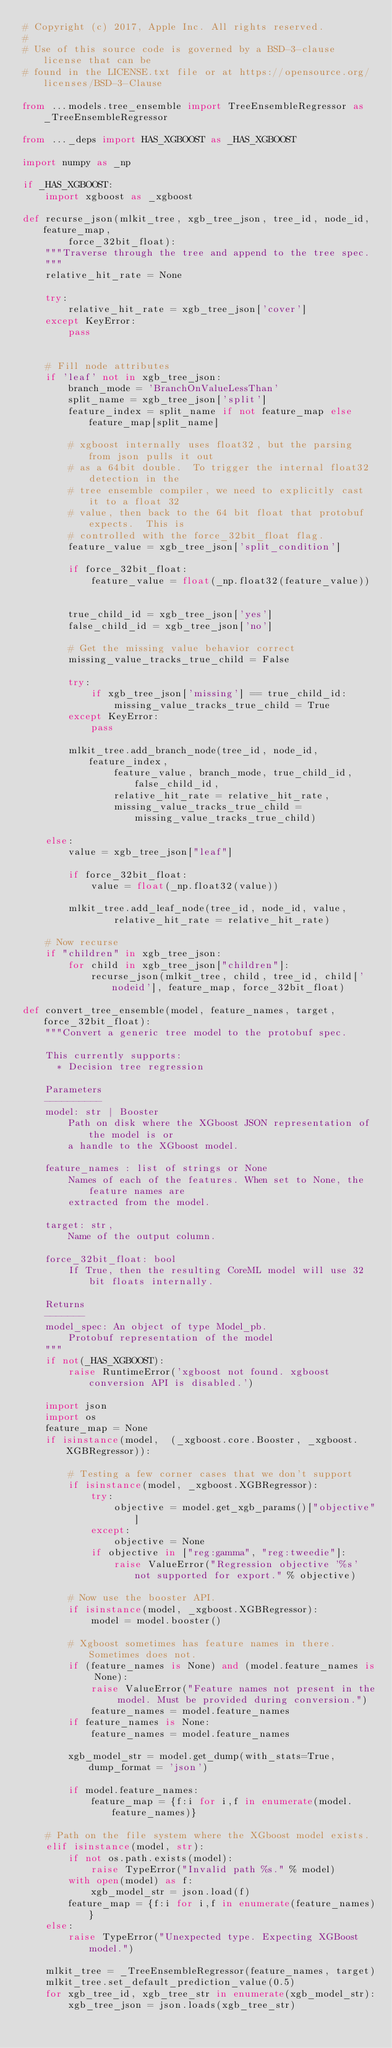<code> <loc_0><loc_0><loc_500><loc_500><_Python_># Copyright (c) 2017, Apple Inc. All rights reserved.
#
# Use of this source code is governed by a BSD-3-clause license that can be
# found in the LICENSE.txt file or at https://opensource.org/licenses/BSD-3-Clause

from ...models.tree_ensemble import TreeEnsembleRegressor as _TreeEnsembleRegressor

from ..._deps import HAS_XGBOOST as _HAS_XGBOOST

import numpy as _np

if _HAS_XGBOOST:
    import xgboost as _xgboost

def recurse_json(mlkit_tree, xgb_tree_json, tree_id, node_id, feature_map, 
        force_32bit_float):
    """Traverse through the tree and append to the tree spec.
    """
    relative_hit_rate = None

    try:
        relative_hit_rate = xgb_tree_json['cover']
    except KeyError:
        pass


    # Fill node attributes
    if 'leaf' not in xgb_tree_json:
        branch_mode = 'BranchOnValueLessThan'
        split_name = xgb_tree_json['split']
        feature_index = split_name if not feature_map else feature_map[split_name]

        # xgboost internally uses float32, but the parsing from json pulls it out
        # as a 64bit double.  To trigger the internal float32 detection in the 
        # tree ensemble compiler, we need to explicitly cast it to a float 32 
        # value, then back to the 64 bit float that protobuf expects.  This is 
        # controlled with the force_32bit_float flag. 
        feature_value = xgb_tree_json['split_condition']

        if force_32bit_float:
            feature_value = float(_np.float32(feature_value))


        true_child_id = xgb_tree_json['yes']
        false_child_id = xgb_tree_json['no']

        # Get the missing value behavior correct
        missing_value_tracks_true_child = False

        try:
            if xgb_tree_json['missing'] == true_child_id:
                missing_value_tracks_true_child = True
        except KeyError:
            pass

        mlkit_tree.add_branch_node(tree_id, node_id, feature_index,
                feature_value, branch_mode, true_child_id, false_child_id,
                relative_hit_rate = relative_hit_rate,
                missing_value_tracks_true_child = missing_value_tracks_true_child)

    else:
        value = xgb_tree_json["leaf"]

        if force_32bit_float:
            value = float(_np.float32(value))  

        mlkit_tree.add_leaf_node(tree_id, node_id, value,
                relative_hit_rate = relative_hit_rate)

    # Now recurse
    if "children" in xgb_tree_json:
        for child in xgb_tree_json["children"]:
            recurse_json(mlkit_tree, child, tree_id, child['nodeid'], feature_map, force_32bit_float)

def convert_tree_ensemble(model, feature_names, target, force_32bit_float):
    """Convert a generic tree model to the protobuf spec.

    This currently supports:
      * Decision tree regression

    Parameters
    ----------
    model: str | Booster
        Path on disk where the XGboost JSON representation of the model is or
        a handle to the XGboost model.

    feature_names : list of strings or None
        Names of each of the features. When set to None, the feature names are
        extracted from the model.

    target: str,
        Name of the output column.

    force_32bit_float: bool
        If True, then the resulting CoreML model will use 32 bit floats internally.

    Returns
    -------
    model_spec: An object of type Model_pb.
        Protobuf representation of the model
    """
    if not(_HAS_XGBOOST):
        raise RuntimeError('xgboost not found. xgboost conversion API is disabled.')
    
    import json
    import os
    feature_map = None
    if isinstance(model,  (_xgboost.core.Booster, _xgboost.XGBRegressor)):

        # Testing a few corner cases that we don't support
        if isinstance(model, _xgboost.XGBRegressor):
            try:
                objective = model.get_xgb_params()["objective"]
            except:
                objective = None
            if objective in ["reg:gamma", "reg:tweedie"]:
                raise ValueError("Regression objective '%s' not supported for export." % objective)

        # Now use the booster API.
        if isinstance(model, _xgboost.XGBRegressor):
            model = model.booster()

        # Xgboost sometimes has feature names in there. Sometimes does not.
        if (feature_names is None) and (model.feature_names is None):
            raise ValueError("Feature names not present in the model. Must be provided during conversion.")
            feature_names = model.feature_names
        if feature_names is None:
            feature_names = model.feature_names

        xgb_model_str = model.get_dump(with_stats=True, dump_format = 'json')

        if model.feature_names:
            feature_map = {f:i for i,f in enumerate(model.feature_names)}

    # Path on the file system where the XGboost model exists.
    elif isinstance(model, str):
        if not os.path.exists(model):
            raise TypeError("Invalid path %s." % model)
        with open(model) as f:
            xgb_model_str = json.load(f)
        feature_map = {f:i for i,f in enumerate(feature_names)}
    else:
        raise TypeError("Unexpected type. Expecting XGBoost model.")

    mlkit_tree = _TreeEnsembleRegressor(feature_names, target)
    mlkit_tree.set_default_prediction_value(0.5)
    for xgb_tree_id, xgb_tree_str in enumerate(xgb_model_str):
        xgb_tree_json = json.loads(xgb_tree_str)</code> 